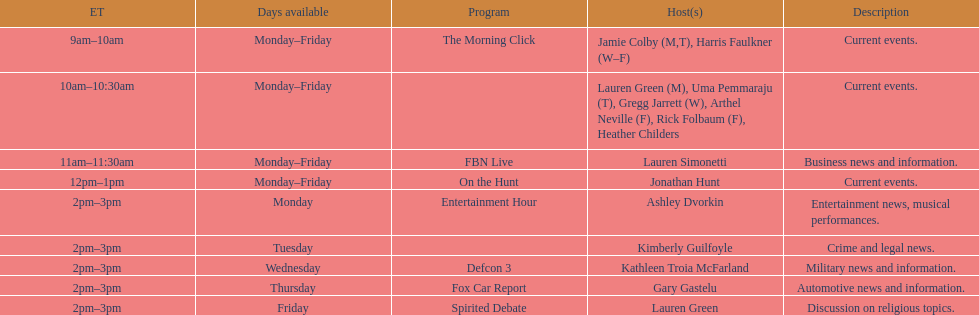What is the first show to play on monday mornings? The Morning Click. 